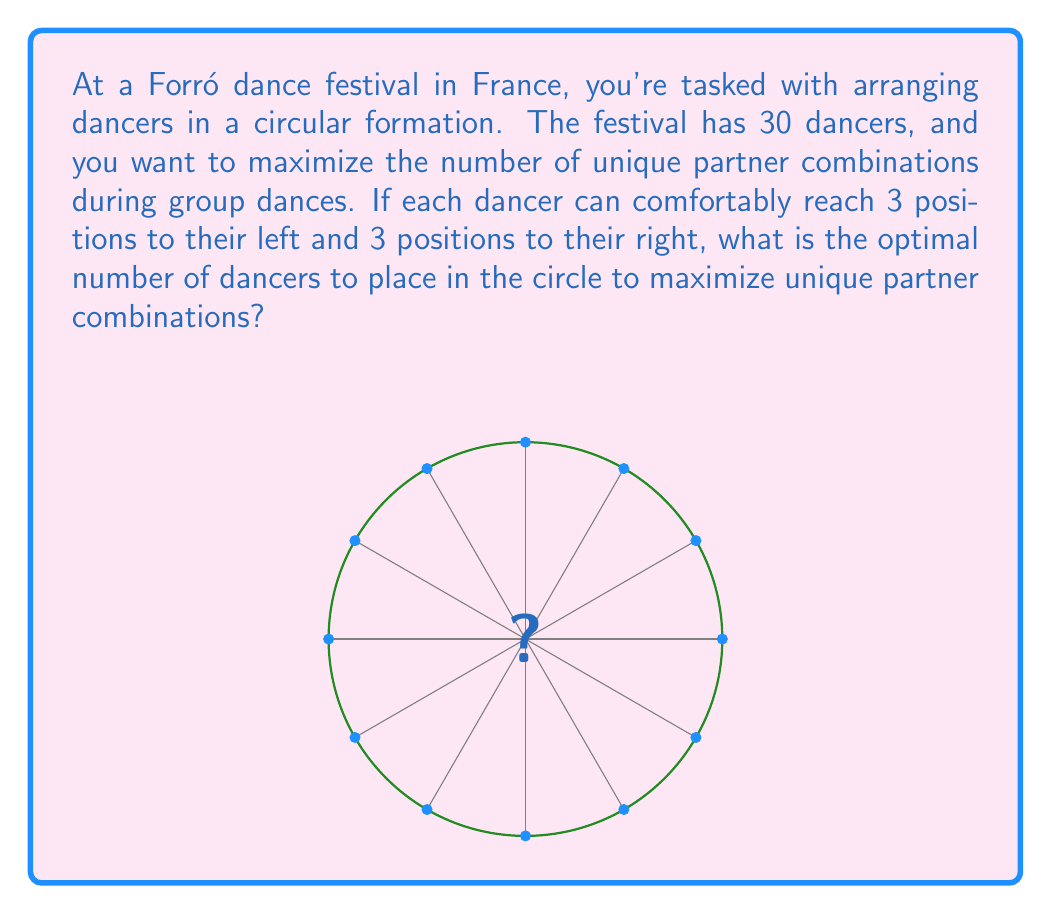Solve this math problem. Let's approach this step-by-step:

1) In a circular formation, each dancer can reach 3 positions to their left and 3 to their right, so they can interact with 6 other dancers in total.

2) The number of unique partner combinations for each dancer is 6, regardless of the total number of dancers in the circle (as long as there are at least 7 dancers).

3) The total number of unique partner combinations in the circle is given by the formula:

   $$ \text{Total combinations} = \frac{n \times 6}{2} $$

   Where $n$ is the number of dancers in the circle. We divide by 2 to avoid counting each partnership twice.

4) We want to maximize this number while using no more than 30 dancers. So we need to find the largest value of $n$ that satisfies:

   $$ n \leq 30 $$

5) The optimal number of dancers will be the largest multiple of 2 less than or equal to 30. This is because an even number of dancers ensures that everyone can have a partner simultaneously.

6) The largest even number less than or equal to 30 is 30 itself.

Therefore, the optimal arrangement is to use all 30 dancers in the circle.

7) The total number of unique partner combinations with 30 dancers would be:

   $$ \text{Total combinations} = \frac{30 \times 6}{2} = 90 $$
Answer: 30 dancers 